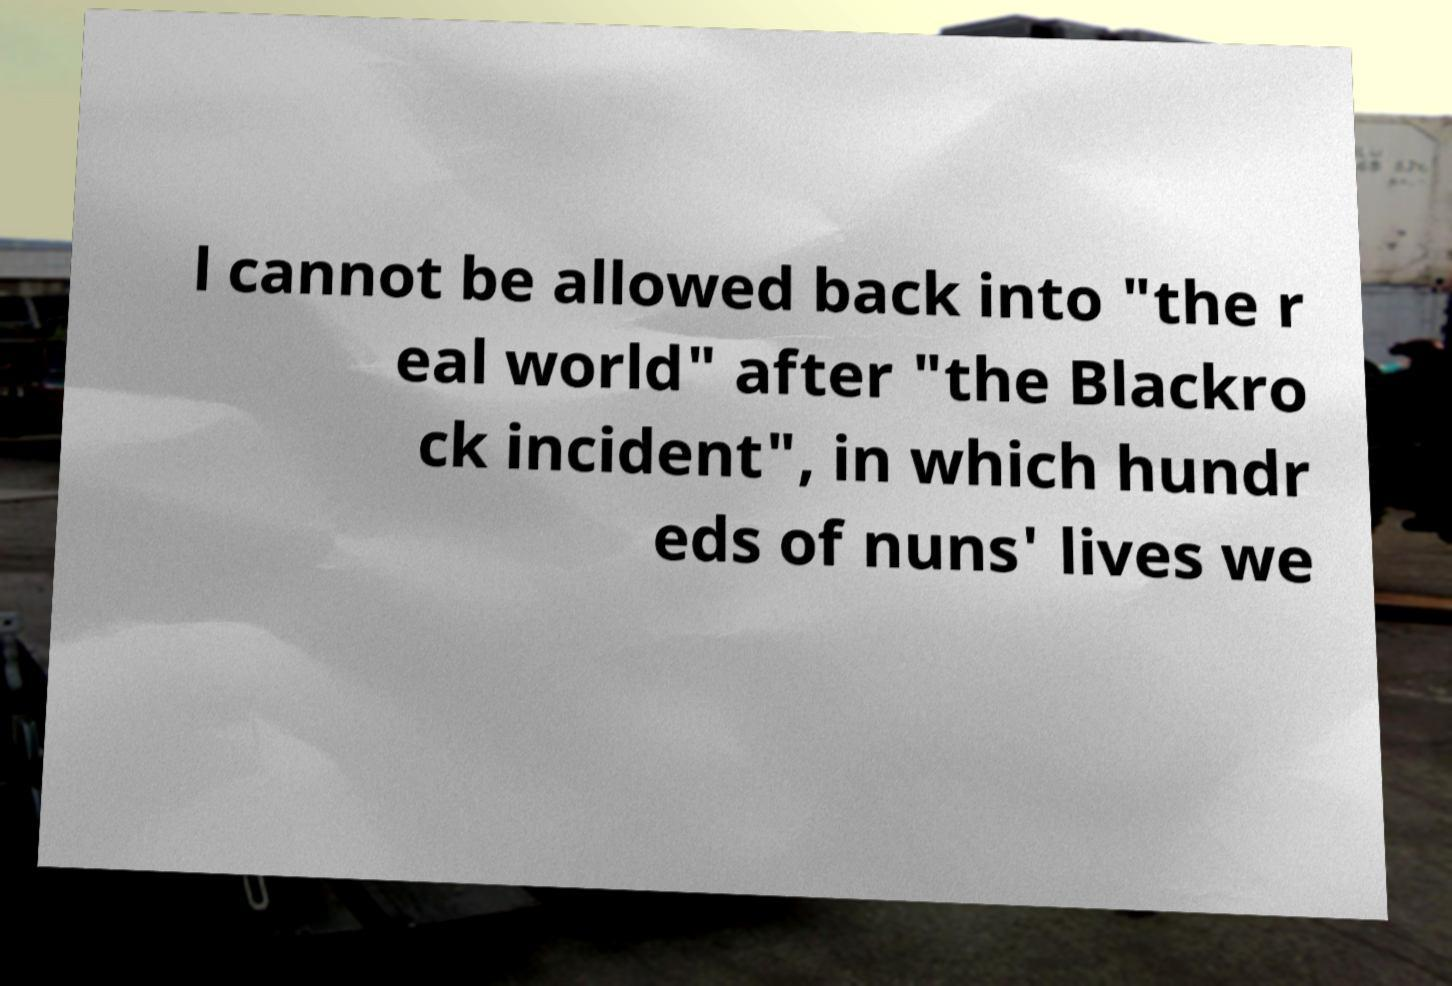For documentation purposes, I need the text within this image transcribed. Could you provide that? l cannot be allowed back into "the r eal world" after "the Blackro ck incident", in which hundr eds of nuns' lives we 